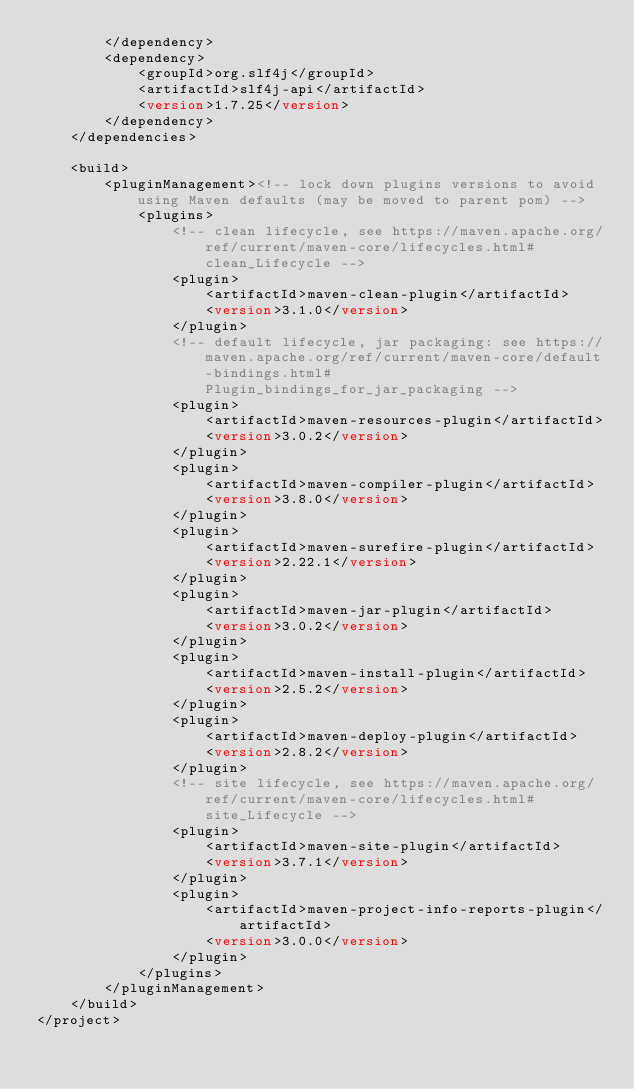<code> <loc_0><loc_0><loc_500><loc_500><_XML_>        </dependency>
        <dependency>
            <groupId>org.slf4j</groupId>
            <artifactId>slf4j-api</artifactId>
            <version>1.7.25</version>
        </dependency>
    </dependencies>

    <build>
        <pluginManagement><!-- lock down plugins versions to avoid using Maven defaults (may be moved to parent pom) -->
            <plugins>
                <!-- clean lifecycle, see https://maven.apache.org/ref/current/maven-core/lifecycles.html#clean_Lifecycle -->
                <plugin>
                    <artifactId>maven-clean-plugin</artifactId>
                    <version>3.1.0</version>
                </plugin>
                <!-- default lifecycle, jar packaging: see https://maven.apache.org/ref/current/maven-core/default-bindings.html#Plugin_bindings_for_jar_packaging -->
                <plugin>
                    <artifactId>maven-resources-plugin</artifactId>
                    <version>3.0.2</version>
                </plugin>
                <plugin>
                    <artifactId>maven-compiler-plugin</artifactId>
                    <version>3.8.0</version>
                </plugin>
                <plugin>
                    <artifactId>maven-surefire-plugin</artifactId>
                    <version>2.22.1</version>
                </plugin>
                <plugin>
                    <artifactId>maven-jar-plugin</artifactId>
                    <version>3.0.2</version>
                </plugin>
                <plugin>
                    <artifactId>maven-install-plugin</artifactId>
                    <version>2.5.2</version>
                </plugin>
                <plugin>
                    <artifactId>maven-deploy-plugin</artifactId>
                    <version>2.8.2</version>
                </plugin>
                <!-- site lifecycle, see https://maven.apache.org/ref/current/maven-core/lifecycles.html#site_Lifecycle -->
                <plugin>
                    <artifactId>maven-site-plugin</artifactId>
                    <version>3.7.1</version>
                </plugin>
                <plugin>
                    <artifactId>maven-project-info-reports-plugin</artifactId>
                    <version>3.0.0</version>
                </plugin>
            </plugins>
        </pluginManagement>
    </build>
</project>
</code> 